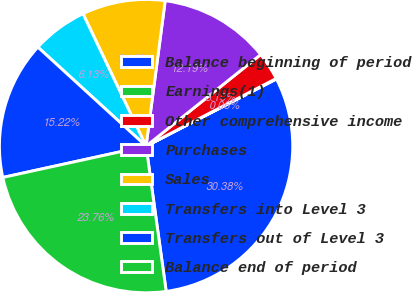<chart> <loc_0><loc_0><loc_500><loc_500><pie_chart><fcel>Balance beginning of period<fcel>Earnings(1)<fcel>Other comprehensive income<fcel>Purchases<fcel>Sales<fcel>Transfers into Level 3<fcel>Transfers out of Level 3<fcel>Balance end of period<nl><fcel>30.38%<fcel>0.06%<fcel>3.1%<fcel>12.19%<fcel>9.16%<fcel>6.13%<fcel>15.22%<fcel>23.76%<nl></chart> 